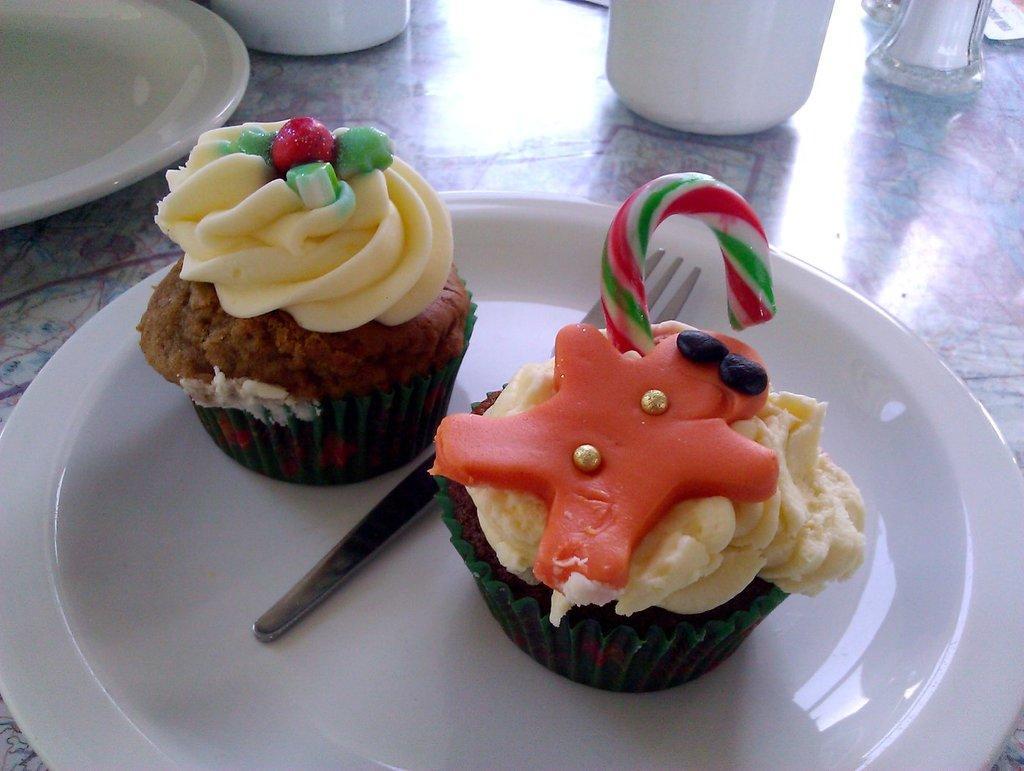In one or two sentences, can you explain what this image depicts? In this image I can two cupcakes on the plate. Also there is another plate and some other objects on the table. 